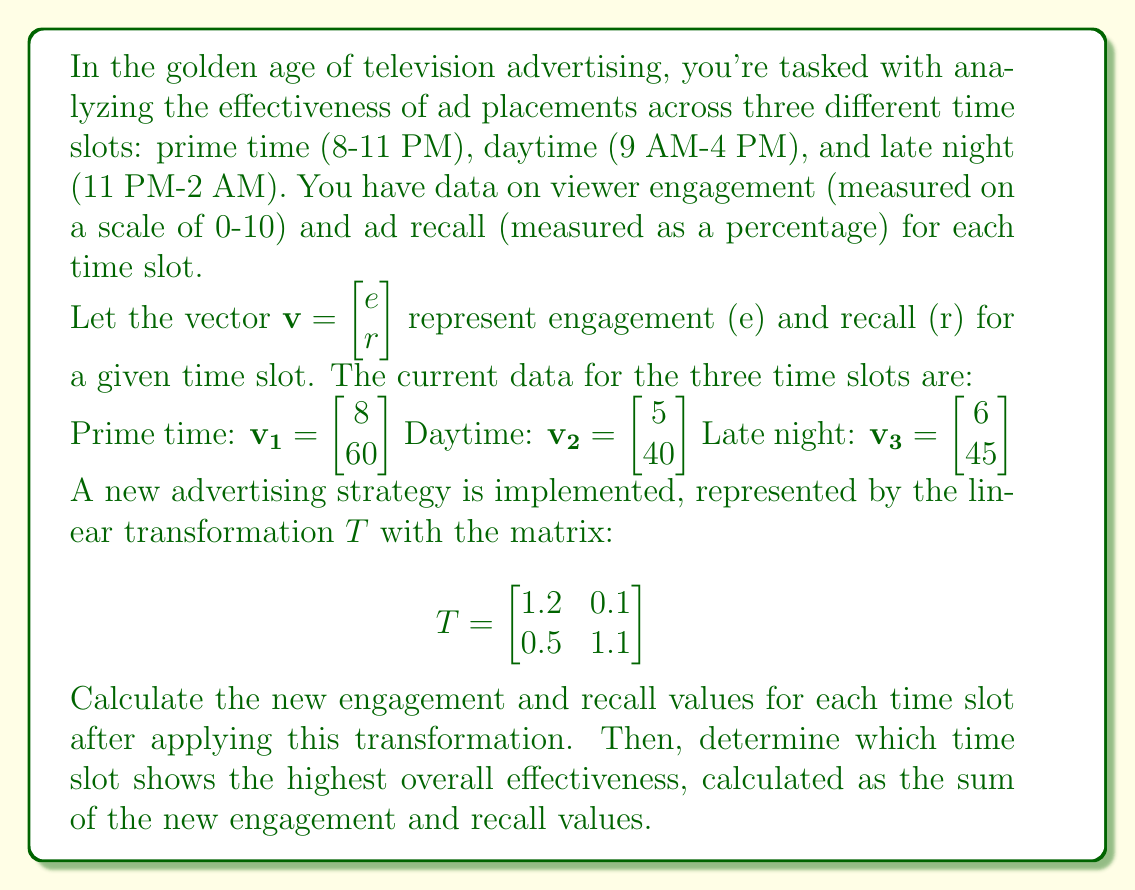Could you help me with this problem? To solve this problem, we need to apply the linear transformation $T$ to each of the initial vectors $\mathbf{v_1}$, $\mathbf{v_2}$, and $\mathbf{v_3}$. Then we'll compare the results to find the most effective time slot.

Step 1: Apply the transformation to each vector.

For prime time $\mathbf{v_1}$:
$$T\mathbf{v_1} = \begin{bmatrix} 1.2 & 0.1 \\ 0.5 & 1.1 \end{bmatrix} \begin{bmatrix} 8 \\ 60 \end{bmatrix} = \begin{bmatrix} (1.2 \times 8) + (0.1 \times 60) \\ (0.5 \times 8) + (1.1 \times 60) \end{bmatrix} = \begin{bmatrix} 15.6 \\ 70 \end{bmatrix}$$

For daytime $\mathbf{v_2}$:
$$T\mathbf{v_2} = \begin{bmatrix} 1.2 & 0.1 \\ 0.5 & 1.1 \end{bmatrix} \begin{bmatrix} 5 \\ 40 \end{bmatrix} = \begin{bmatrix} (1.2 \times 5) + (0.1 \times 40) \\ (0.5 \times 5) + (1.1 \times 40) \end{bmatrix} = \begin{bmatrix} 10 \\ 46.5 \end{bmatrix}$$

For late night $\mathbf{v_3}$:
$$T\mathbf{v_3} = \begin{bmatrix} 1.2 & 0.1 \\ 0.5 & 1.1 \end{bmatrix} \begin{bmatrix} 6 \\ 45 \end{bmatrix} = \begin{bmatrix} (1.2 \times 6) + (0.1 \times 45) \\ (0.5 \times 6) + (1.1 \times 45) \end{bmatrix} = \begin{bmatrix} 11.7 \\ 52.5 \end{bmatrix}$$

Step 2: Calculate the overall effectiveness for each time slot by summing the new engagement and recall values.

Prime time: $15.6 + 70 = 85.6$
Daytime: $10 + 46.5 = 56.5$
Late night: $11.7 + 52.5 = 64.2$

Step 3: Compare the overall effectiveness values to determine the most effective time slot.

The highest overall effectiveness is 85.6, corresponding to the prime time slot.
Answer: After applying the transformation, the prime time slot shows the highest overall effectiveness with a score of 85.6. 